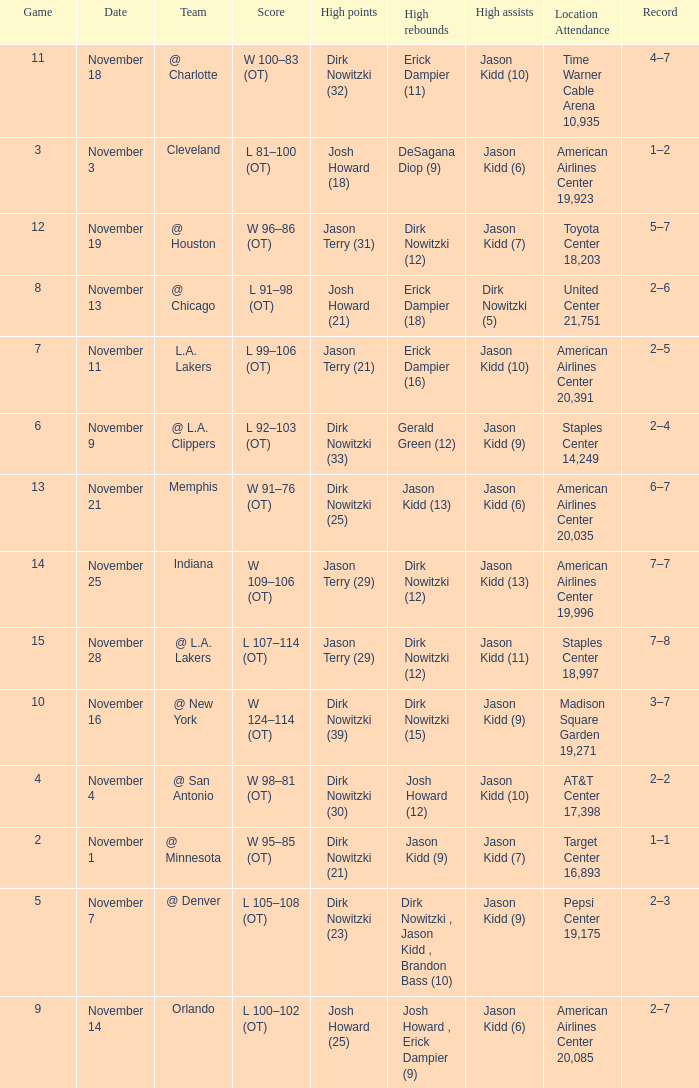What was the record on November 7? 1.0. 